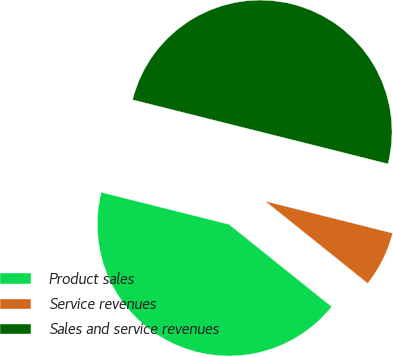<chart> <loc_0><loc_0><loc_500><loc_500><pie_chart><fcel>Product sales<fcel>Service revenues<fcel>Sales and service revenues<nl><fcel>43.16%<fcel>6.84%<fcel>50.0%<nl></chart> 